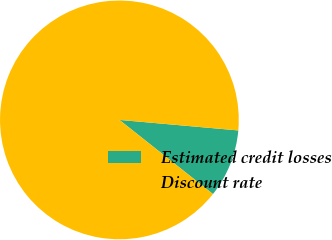Convert chart to OTSL. <chart><loc_0><loc_0><loc_500><loc_500><pie_chart><fcel>Estimated credit losses<fcel>Discount rate<nl><fcel>9.26%<fcel>90.74%<nl></chart> 